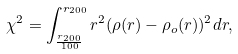<formula> <loc_0><loc_0><loc_500><loc_500>\chi ^ { 2 } = \int _ { \frac { r _ { 2 0 0 } } { 1 0 0 } } ^ { r _ { 2 0 0 } } r ^ { 2 } ( \rho ( r ) - \rho _ { o } ( r ) ) ^ { 2 } d r ,</formula> 